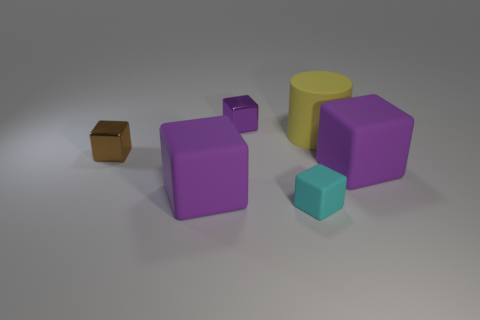Subtract all red cylinders. How many purple cubes are left? 3 Subtract all brown blocks. How many blocks are left? 4 Subtract all purple shiny blocks. How many blocks are left? 4 Subtract all yellow blocks. Subtract all red cylinders. How many blocks are left? 5 Add 3 big yellow rubber things. How many objects exist? 9 Subtract all cubes. How many objects are left? 1 Add 1 small metallic things. How many small metallic things are left? 3 Add 3 small purple metallic cubes. How many small purple metallic cubes exist? 4 Subtract 0 purple balls. How many objects are left? 6 Subtract all cyan things. Subtract all tiny cyan blocks. How many objects are left? 4 